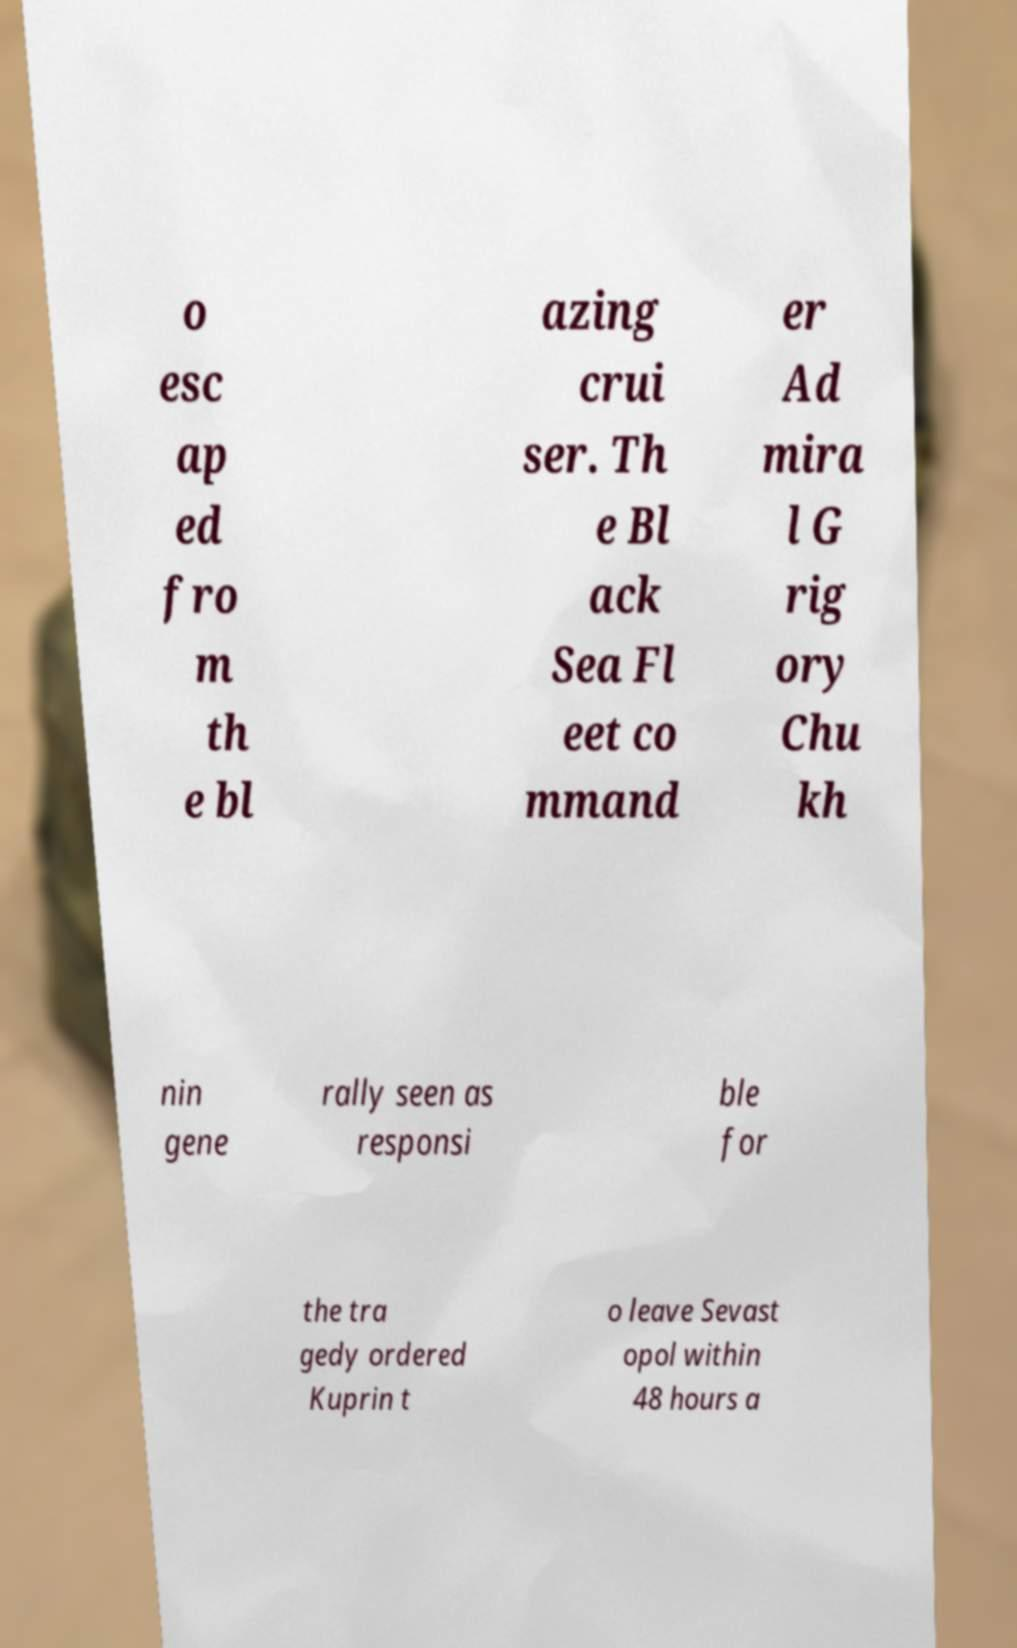I need the written content from this picture converted into text. Can you do that? o esc ap ed fro m th e bl azing crui ser. Th e Bl ack Sea Fl eet co mmand er Ad mira l G rig ory Chu kh nin gene rally seen as responsi ble for the tra gedy ordered Kuprin t o leave Sevast opol within 48 hours a 